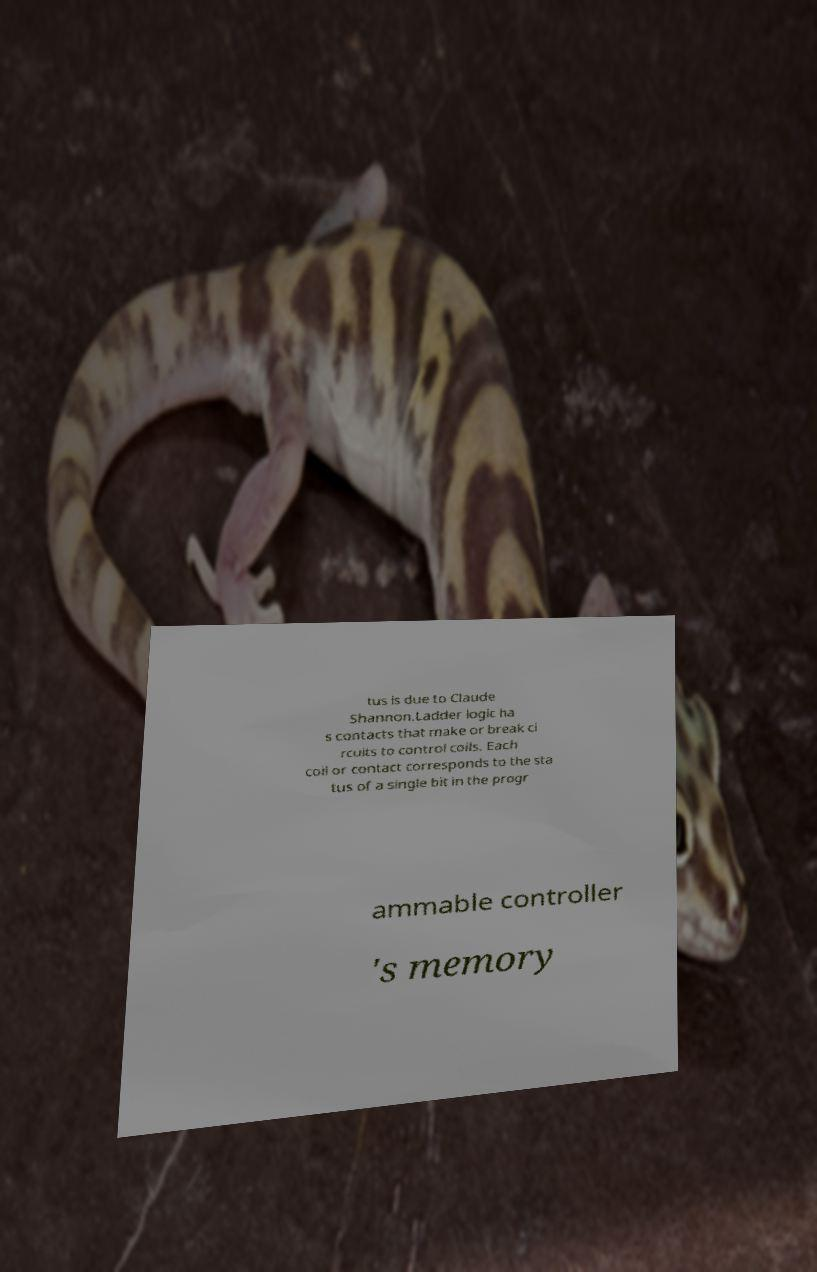Can you accurately transcribe the text from the provided image for me? tus is due to Claude Shannon.Ladder logic ha s contacts that make or break ci rcuits to control coils. Each coil or contact corresponds to the sta tus of a single bit in the progr ammable controller 's memory 